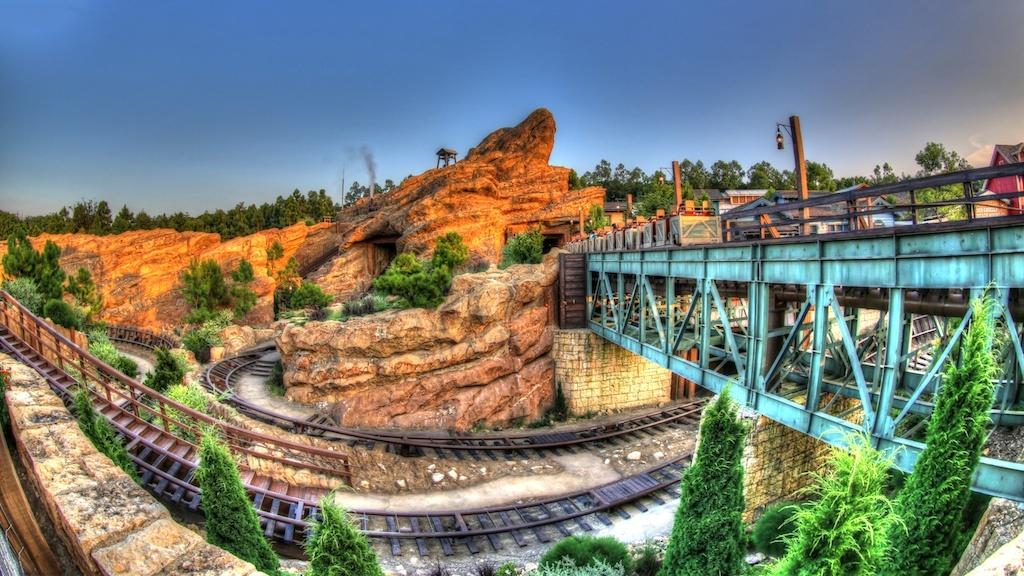What type of structure can be seen in the image? There is a bridge in the image. What type of buildings are present in the image? There are houses in the image. What are the wooden poles used for in the image? The wooden poles are present in the image, but their purpose is not specified. What type of vegetation is visible in the image? Trees are visible in the image. What type of transportation infrastructure is present in the image? Railway tracks are in the image. What type of natural feature is present in the image? Rocks are present in the image. What type of man-made structures are visible in the image? Walls are visible in the image. What type of byproduct is present in the image? Smoke is present in the image. What type of small dwelling is present in the image? There is a hut in the image. What can be seen in the background of the image? The sky is visible in the background of the image. What type of toothpaste is being advertised on the bridge in the image? There is no toothpaste being advertised or present in the image. What type of society is depicted in the image? The image does not depict a society; it shows a bridge, houses, trees, and other elements. 